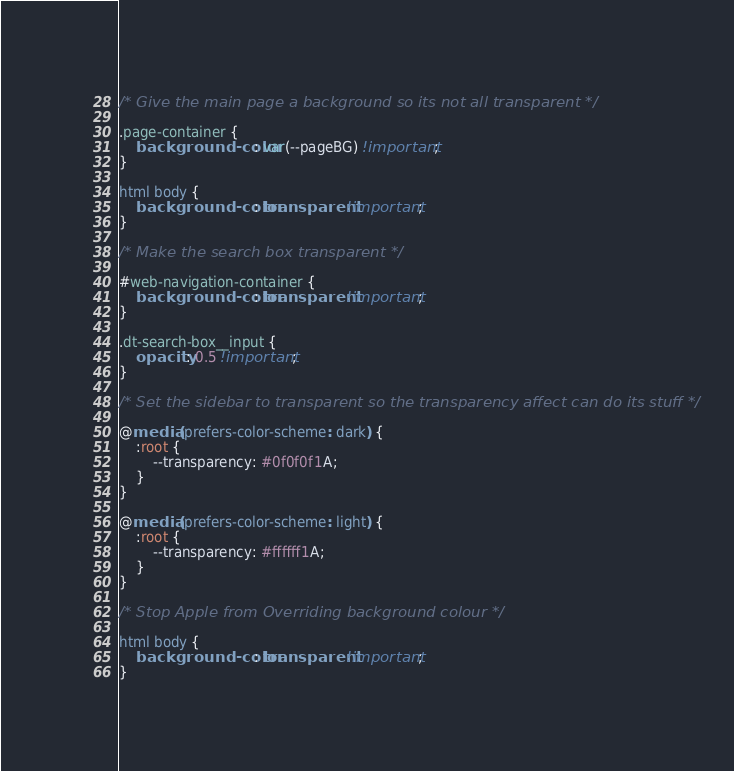Convert code to text. <code><loc_0><loc_0><loc_500><loc_500><_CSS_>/* Give the main page a background so its not all transparent */

.page-container {
    background-color: var(--pageBG) !important;
}

html body {
    background-color: transparent !important;
}

/* Make the search box transparent */

#web-navigation-container {
    background-color: transparent !important;
}

.dt-search-box__input {
    opacity: 0.5 !important;
}

/* Set the sidebar to transparent so the transparency affect can do its stuff */

@media (prefers-color-scheme: dark) {
    :root {
        --transparency: #0f0f0f1A;
    }
}

@media (prefers-color-scheme: light) {
    :root {
        --transparency: #ffffff1A;
    }
}

/* Stop Apple from Overriding background colour */

html body {
    background-color: transparent !important;
}</code> 